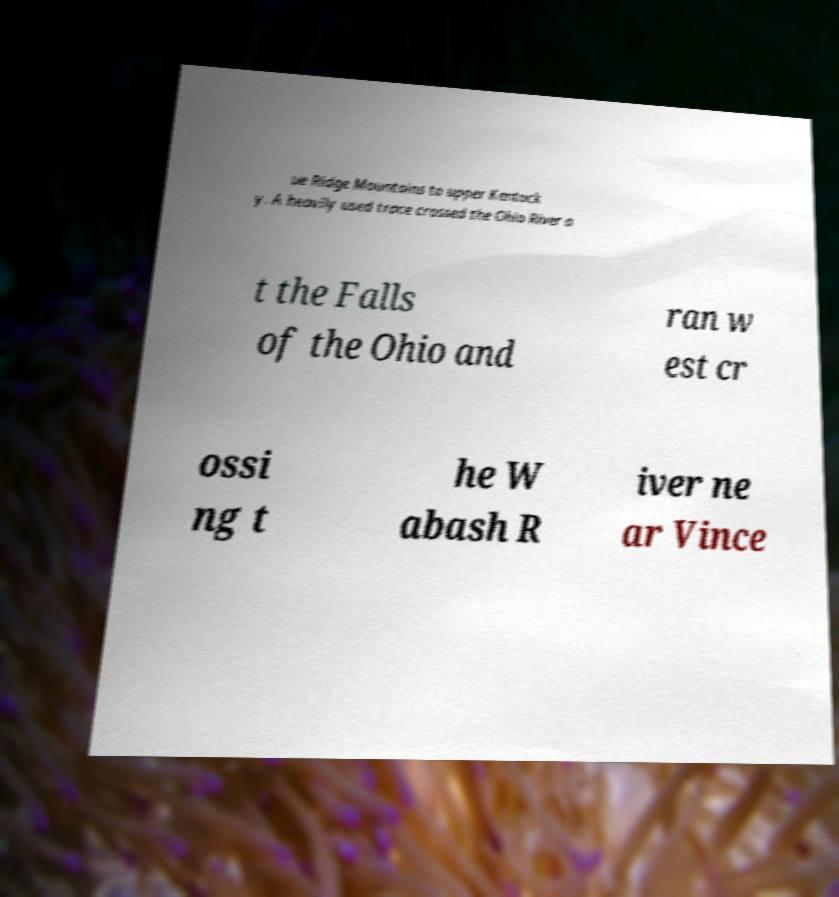Please read and relay the text visible in this image. What does it say? ue Ridge Mountains to upper Kentuck y. A heavily used trace crossed the Ohio River a t the Falls of the Ohio and ran w est cr ossi ng t he W abash R iver ne ar Vince 